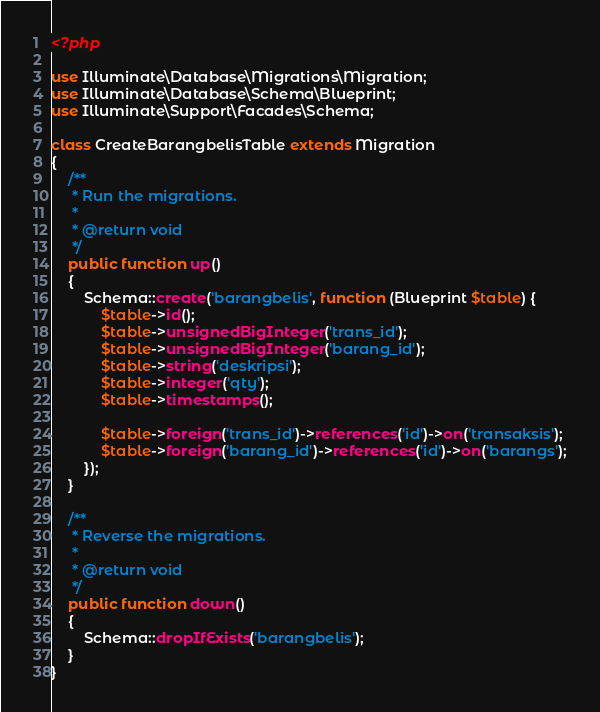<code> <loc_0><loc_0><loc_500><loc_500><_PHP_><?php

use Illuminate\Database\Migrations\Migration;
use Illuminate\Database\Schema\Blueprint;
use Illuminate\Support\Facades\Schema;

class CreateBarangbelisTable extends Migration
{
    /**
     * Run the migrations.
     *
     * @return void
     */
    public function up()
    {
        Schema::create('barangbelis', function (Blueprint $table) {
            $table->id();
            $table->unsignedBigInteger('trans_id');
            $table->unsignedBigInteger('barang_id');
            $table->string('deskripsi');
            $table->integer('qty');
            $table->timestamps();

            $table->foreign('trans_id')->references('id')->on('transaksis');
            $table->foreign('barang_id')->references('id')->on('barangs');
        });
    }

    /**
     * Reverse the migrations.
     *
     * @return void
     */
    public function down()
    {
        Schema::dropIfExists('barangbelis');
    }
}
</code> 